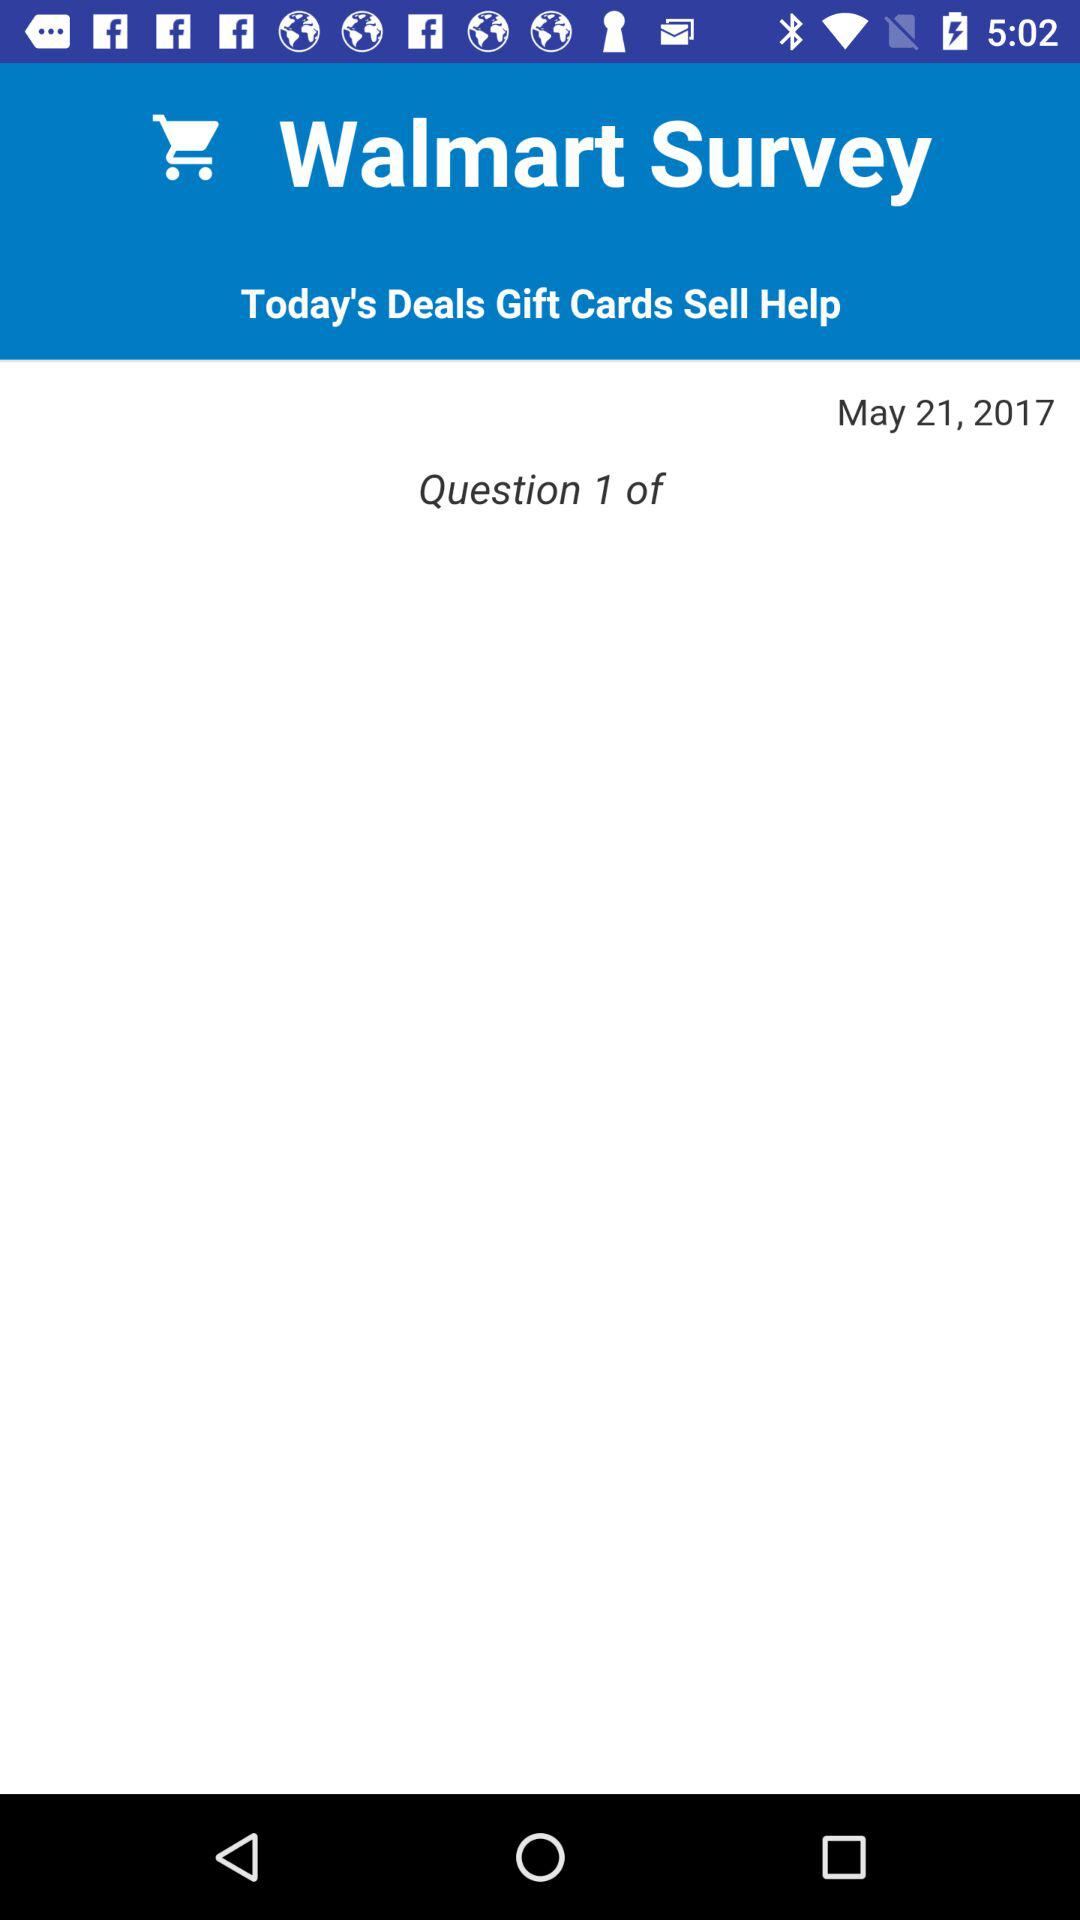What's the question number? The question number is 1. 